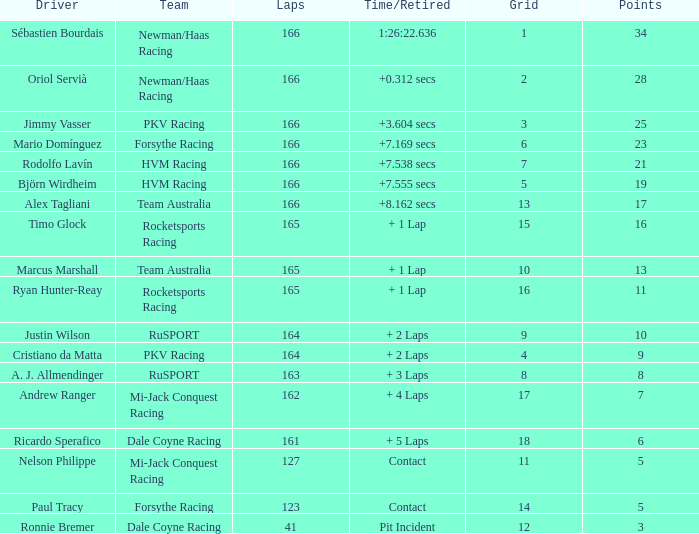Driver Ricardo Sperafico has what as his average laps? 161.0. Would you mind parsing the complete table? {'header': ['Driver', 'Team', 'Laps', 'Time/Retired', 'Grid', 'Points'], 'rows': [['Sébastien Bourdais', 'Newman/Haas Racing', '166', '1:26:22.636', '1', '34'], ['Oriol Servià', 'Newman/Haas Racing', '166', '+0.312 secs', '2', '28'], ['Jimmy Vasser', 'PKV Racing', '166', '+3.604 secs', '3', '25'], ['Mario Domínguez', 'Forsythe Racing', '166', '+7.169 secs', '6', '23'], ['Rodolfo Lavín', 'HVM Racing', '166', '+7.538 secs', '7', '21'], ['Björn Wirdheim', 'HVM Racing', '166', '+7.555 secs', '5', '19'], ['Alex Tagliani', 'Team Australia', '166', '+8.162 secs', '13', '17'], ['Timo Glock', 'Rocketsports Racing', '165', '+ 1 Lap', '15', '16'], ['Marcus Marshall', 'Team Australia', '165', '+ 1 Lap', '10', '13'], ['Ryan Hunter-Reay', 'Rocketsports Racing', '165', '+ 1 Lap', '16', '11'], ['Justin Wilson', 'RuSPORT', '164', '+ 2 Laps', '9', '10'], ['Cristiano da Matta', 'PKV Racing', '164', '+ 2 Laps', '4', '9'], ['A. J. Allmendinger', 'RuSPORT', '163', '+ 3 Laps', '8', '8'], ['Andrew Ranger', 'Mi-Jack Conquest Racing', '162', '+ 4 Laps', '17', '7'], ['Ricardo Sperafico', 'Dale Coyne Racing', '161', '+ 5 Laps', '18', '6'], ['Nelson Philippe', 'Mi-Jack Conquest Racing', '127', 'Contact', '11', '5'], ['Paul Tracy', 'Forsythe Racing', '123', 'Contact', '14', '5'], ['Ronnie Bremer', 'Dale Coyne Racing', '41', 'Pit Incident', '12', '3']]} 